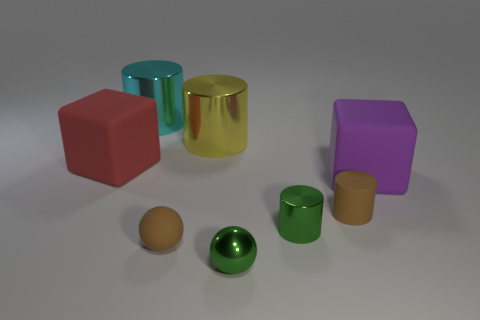Subtract all rubber cylinders. How many cylinders are left? 3 Subtract all yellow cylinders. How many cylinders are left? 3 Subtract 2 cylinders. How many cylinders are left? 2 Add 1 tiny green metal objects. How many objects exist? 9 Subtract all blue cylinders. Subtract all gray blocks. How many cylinders are left? 4 Subtract all spheres. How many objects are left? 6 Subtract all tiny cubes. Subtract all tiny brown things. How many objects are left? 6 Add 2 spheres. How many spheres are left? 4 Add 3 cubes. How many cubes exist? 5 Subtract 0 gray cylinders. How many objects are left? 8 